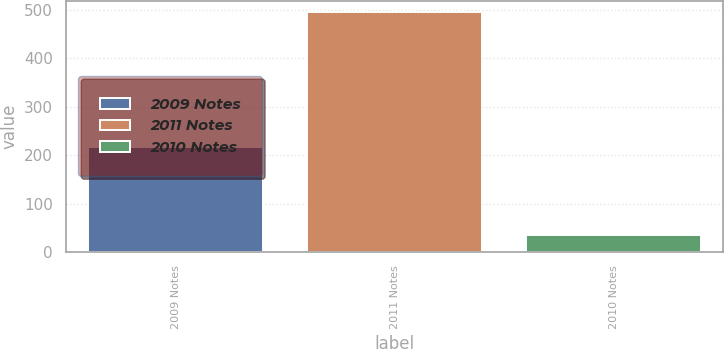<chart> <loc_0><loc_0><loc_500><loc_500><bar_chart><fcel>2009 Notes<fcel>2011 Notes<fcel>2010 Notes<nl><fcel>217.3<fcel>494.2<fcel>36.4<nl></chart> 